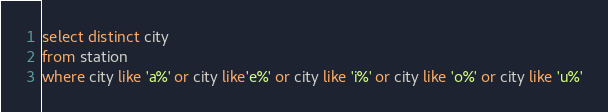Convert code to text. <code><loc_0><loc_0><loc_500><loc_500><_SQL_>select distinct city
from station
where city like 'a%' or city like'e%' or city like 'i%' or city like 'o%' or city like 'u%'

</code> 